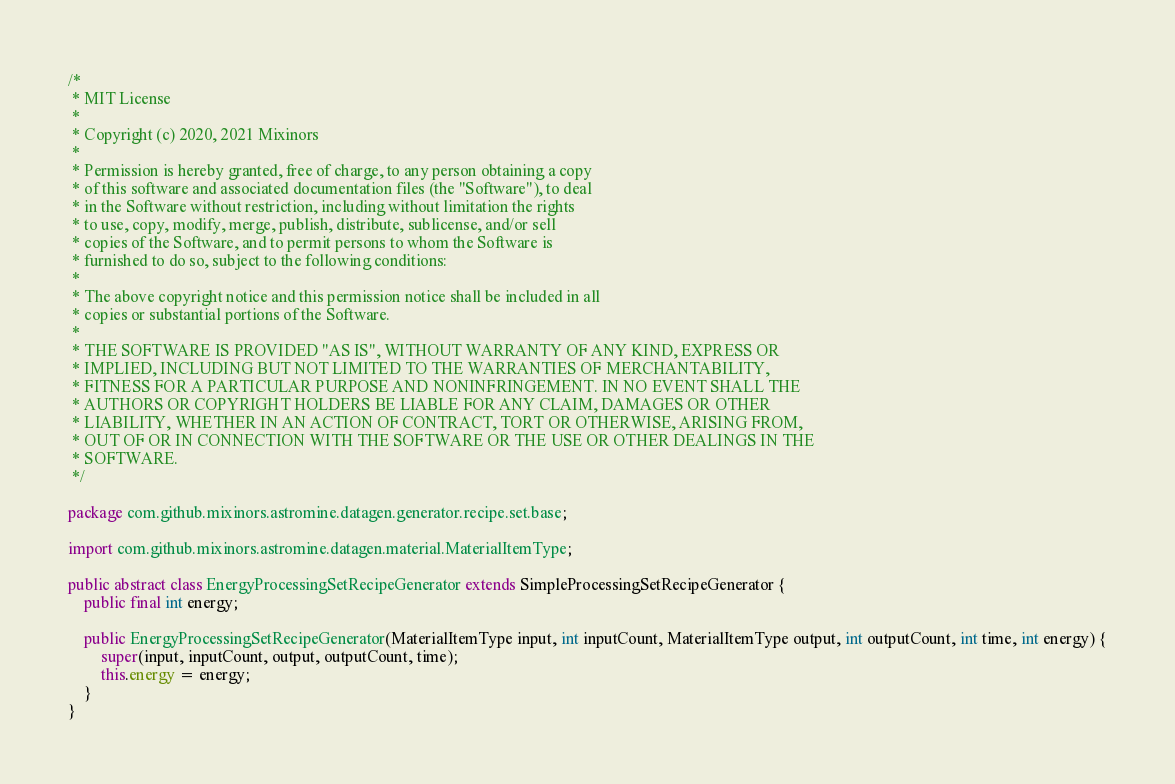Convert code to text. <code><loc_0><loc_0><loc_500><loc_500><_Java_>/*
 * MIT License
 *
 * Copyright (c) 2020, 2021 Mixinors
 *
 * Permission is hereby granted, free of charge, to any person obtaining a copy
 * of this software and associated documentation files (the "Software"), to deal
 * in the Software without restriction, including without limitation the rights
 * to use, copy, modify, merge, publish, distribute, sublicense, and/or sell
 * copies of the Software, and to permit persons to whom the Software is
 * furnished to do so, subject to the following conditions:
 *
 * The above copyright notice and this permission notice shall be included in all
 * copies or substantial portions of the Software.
 *
 * THE SOFTWARE IS PROVIDED "AS IS", WITHOUT WARRANTY OF ANY KIND, EXPRESS OR
 * IMPLIED, INCLUDING BUT NOT LIMITED TO THE WARRANTIES OF MERCHANTABILITY,
 * FITNESS FOR A PARTICULAR PURPOSE AND NONINFRINGEMENT. IN NO EVENT SHALL THE
 * AUTHORS OR COPYRIGHT HOLDERS BE LIABLE FOR ANY CLAIM, DAMAGES OR OTHER
 * LIABILITY, WHETHER IN AN ACTION OF CONTRACT, TORT OR OTHERWISE, ARISING FROM,
 * OUT OF OR IN CONNECTION WITH THE SOFTWARE OR THE USE OR OTHER DEALINGS IN THE
 * SOFTWARE.
 */

package com.github.mixinors.astromine.datagen.generator.recipe.set.base;

import com.github.mixinors.astromine.datagen.material.MaterialItemType;

public abstract class EnergyProcessingSetRecipeGenerator extends SimpleProcessingSetRecipeGenerator {
	public final int energy;

	public EnergyProcessingSetRecipeGenerator(MaterialItemType input, int inputCount, MaterialItemType output, int outputCount, int time, int energy) {
		super(input, inputCount, output, outputCount, time);
		this.energy = energy;
	}
}
</code> 